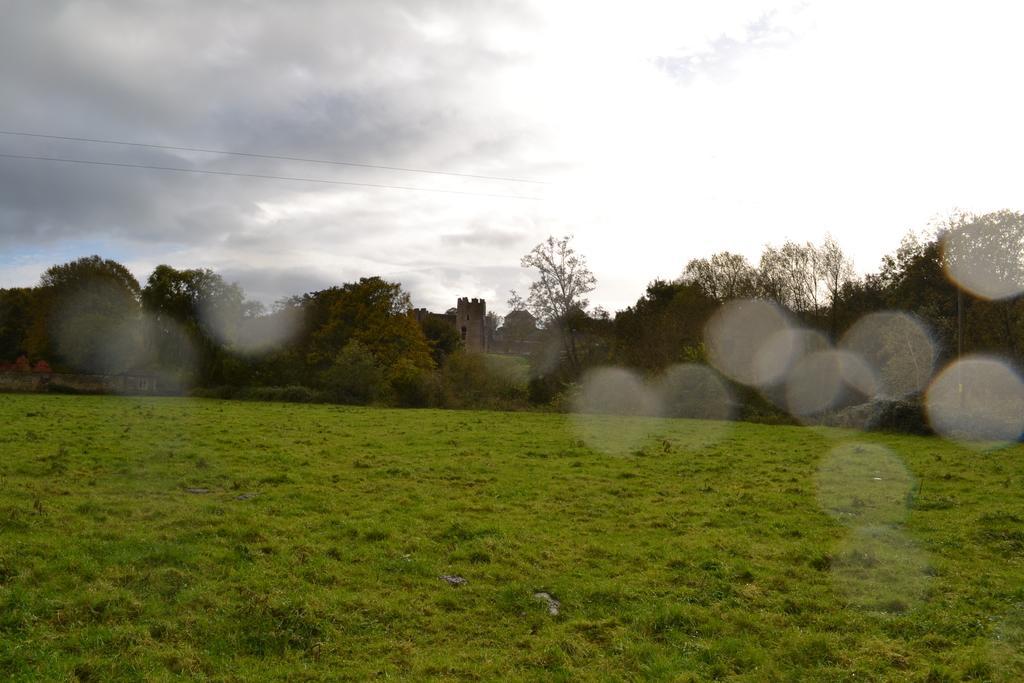In one or two sentences, can you explain what this image depicts? In the picture we can see a grass surface and far from it, we can see trees and plants and behind it, we can see some historical construction and in the background we can see a sky with clouds. 